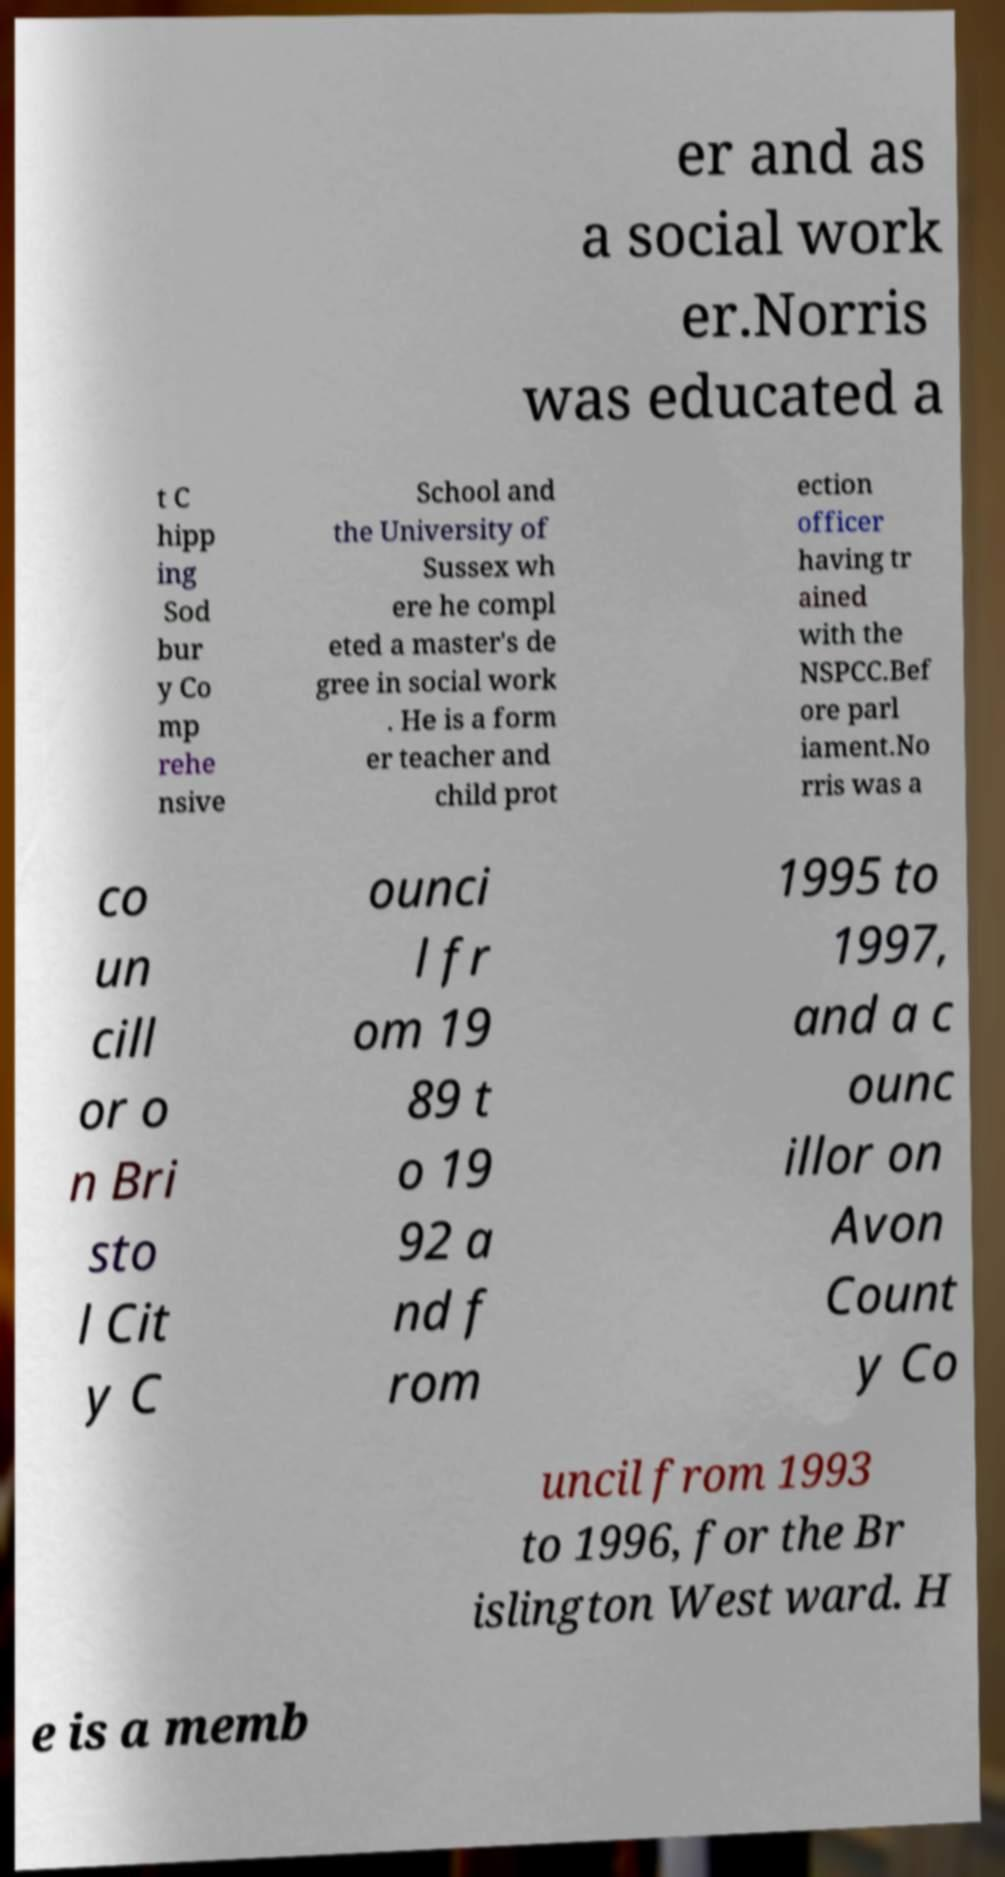Can you read and provide the text displayed in the image?This photo seems to have some interesting text. Can you extract and type it out for me? er and as a social work er.Norris was educated a t C hipp ing Sod bur y Co mp rehe nsive School and the University of Sussex wh ere he compl eted a master's de gree in social work . He is a form er teacher and child prot ection officer having tr ained with the NSPCC.Bef ore parl iament.No rris was a co un cill or o n Bri sto l Cit y C ounci l fr om 19 89 t o 19 92 a nd f rom 1995 to 1997, and a c ounc illor on Avon Count y Co uncil from 1993 to 1996, for the Br islington West ward. H e is a memb 